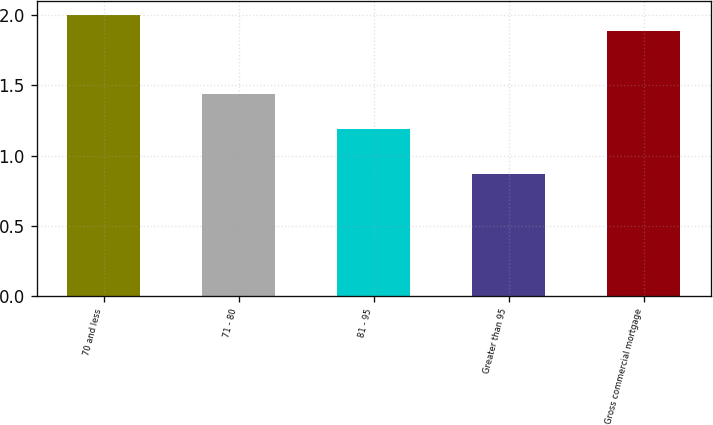<chart> <loc_0><loc_0><loc_500><loc_500><bar_chart><fcel>70 and less<fcel>71 - 80<fcel>81 - 95<fcel>Greater than 95<fcel>Gross commercial mortgage<nl><fcel>2<fcel>1.44<fcel>1.19<fcel>0.87<fcel>1.89<nl></chart> 